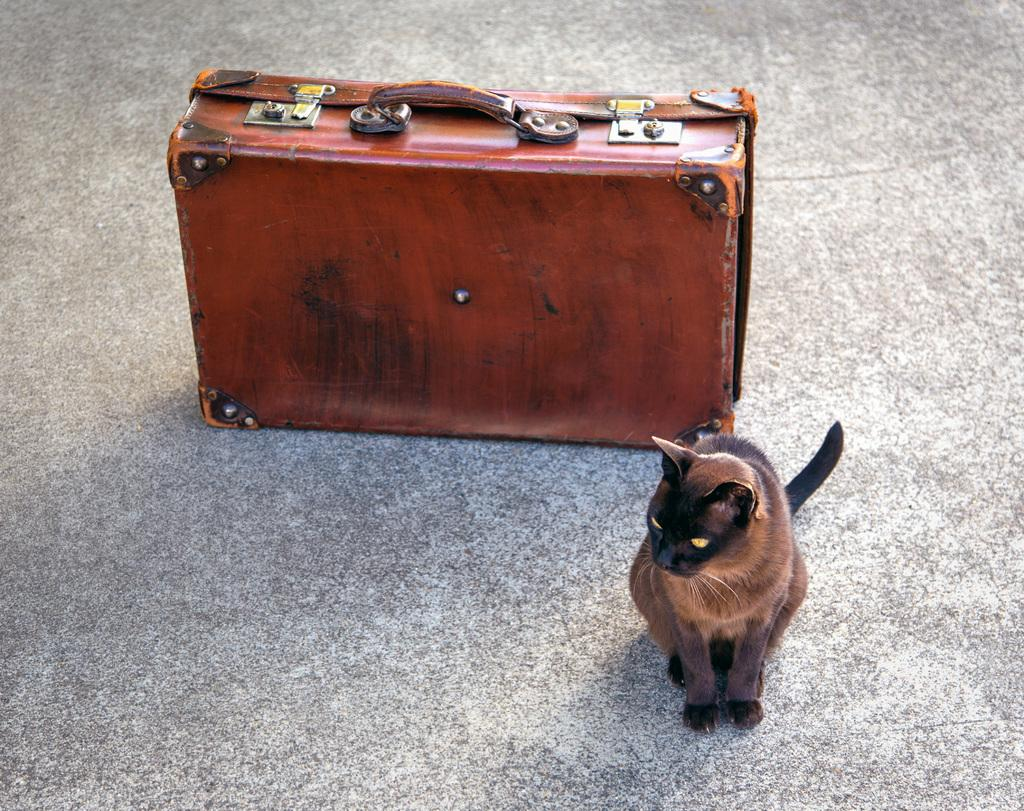What animal can be seen sitting on the floor in the image? There is a cat sitting on the floor in the image. What type of luggage is present in the image? There is a suitcase with a handle in the image. What is the color of the suitcase? The suitcase is brown in color. How is the suitcase secured? There is a lock attached to the suitcase. What type of wrench is being used to tighten the edge of the cat's collar in the image? There is no wrench or collar present in the image; it features a cat sitting on the floor and a brown suitcase with a handle and a lock. 